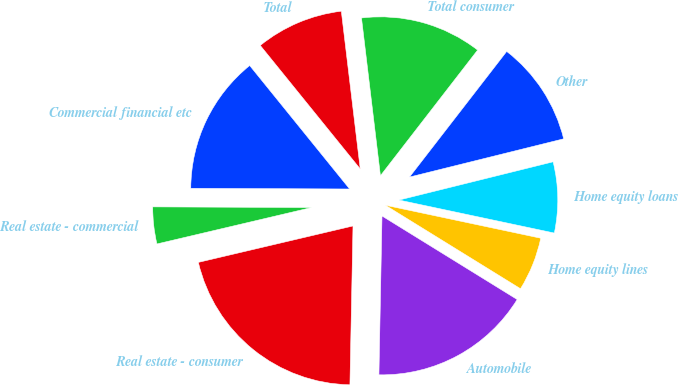<chart> <loc_0><loc_0><loc_500><loc_500><pie_chart><fcel>Commercial financial etc<fcel>Real estate - commercial<fcel>Real estate - consumer<fcel>Automobile<fcel>Home equity lines<fcel>Home equity loans<fcel>Other<fcel>Total consumer<fcel>Total<nl><fcel>14.1%<fcel>3.75%<fcel>21.01%<fcel>16.5%<fcel>5.48%<fcel>7.2%<fcel>10.65%<fcel>12.38%<fcel>8.93%<nl></chart> 